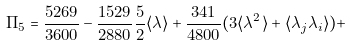<formula> <loc_0><loc_0><loc_500><loc_500>\Pi _ { 5 } = \frac { 5 2 6 9 } { 3 6 0 0 } - \frac { 1 5 2 9 } { 2 8 8 0 } \frac { 5 } { 2 } \langle \lambda \rangle + \frac { 3 4 1 } { 4 8 0 0 } ( 3 \langle \lambda ^ { 2 } \rangle + \langle \lambda _ { j } \lambda _ { i } \rangle ) +</formula> 